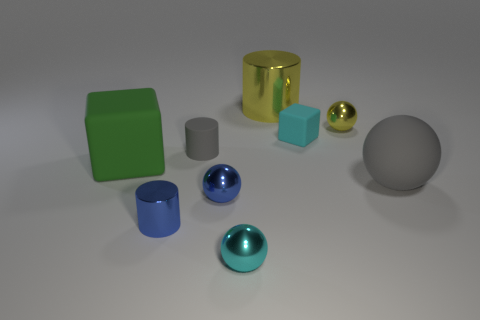Subtract all cubes. How many objects are left? 7 Subtract 1 cyan spheres. How many objects are left? 8 Subtract all large red spheres. Subtract all tiny blue metal spheres. How many objects are left? 8 Add 1 small gray cylinders. How many small gray cylinders are left? 2 Add 5 tiny blue metallic objects. How many tiny blue metallic objects exist? 7 